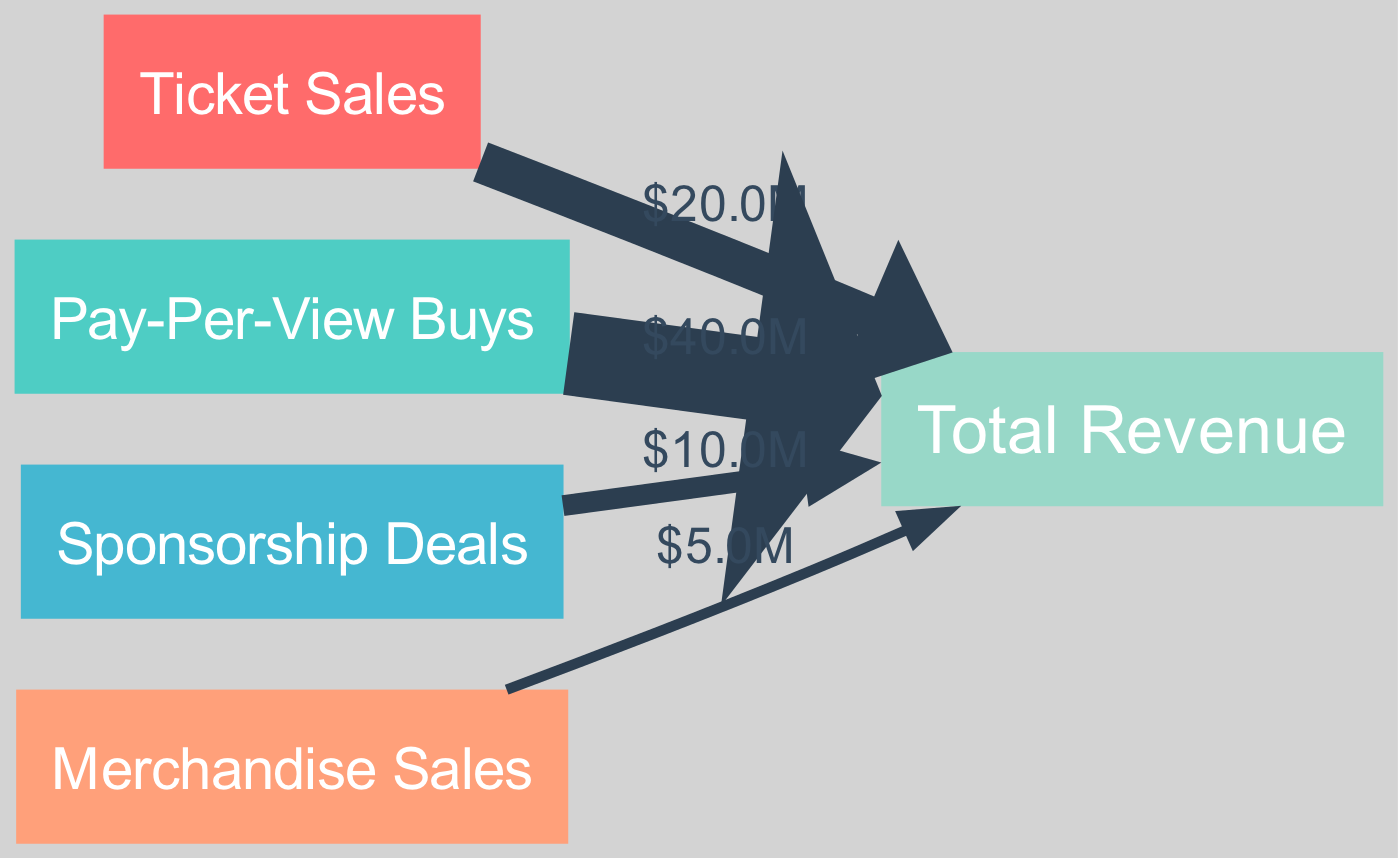What is the total revenue from ticket sales? The diagram indicates that the ticket sales contribute a revenue of $20 million to the total revenue, which is represented by the link from the "Ticket Sales" node to the "Total Revenue" node.
Answer: 20000000 How much revenue comes from pay-per-view buys? The node "Pay-Per-View Buys" shows a revenue contribution of $40 million, indicated by the link leading from this node to the "Total Revenue" node.
Answer: 40000000 How many revenue streams are represented in this diagram? The diagram includes four distinct revenue sources: Ticket Sales, Pay-Per-View Buys, Sponsorship Deals, and Merchandise Sales, all contributing to the "Total Revenue" node. Therefore, there are four revenue streams.
Answer: 4 What is the revenue from sponsorship deals? The diagram shows the revenue from "Sponsorship Deals" as $10 million, as indicated by the link between this node and the "Total Revenue" node.
Answer: 10000000 What is the least contributing revenue stream? Upon examining the links, "Merchandise Sales" contributes the least revenue of $5 million to the "Total Revenue", as indicated by the width of the link and numerical value.
Answer: 5000000 What is the total combined revenue from all sources? By adding the individual contributions from the four revenue streams (20 million + 40 million + 10 million + 5 million) as shown in the diagram, the total revenue is calculated as $75 million.
Answer: 75000000 How much of the total revenue comes from ticket sales and merchandise sales combined? The ticket sales contribute $20 million and merchandise sales contribute $5 million. Adding these two values gives a combined revenue from these sources of $25 million.
Answer: 25000000 Which revenue stream represents the highest amount? The "Pay-Per-View Buys" node has the highest contribution indicated, with a revenue of $40 million flowing towards the "Total Revenue" node, which is greater than the other streams.
Answer: Pay-Per-View Buys What is the ratio of merchandise sales to sponsorship deals? The "Merchandise Sales" amount is $5 million while "Sponsorship Deals" amount to $10 million. The ratio can be expressed as 5 to 10 or simplified to 1 to 2.
Answer: 1 to 2 